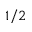<formula> <loc_0><loc_0><loc_500><loc_500>1 / 2</formula> 